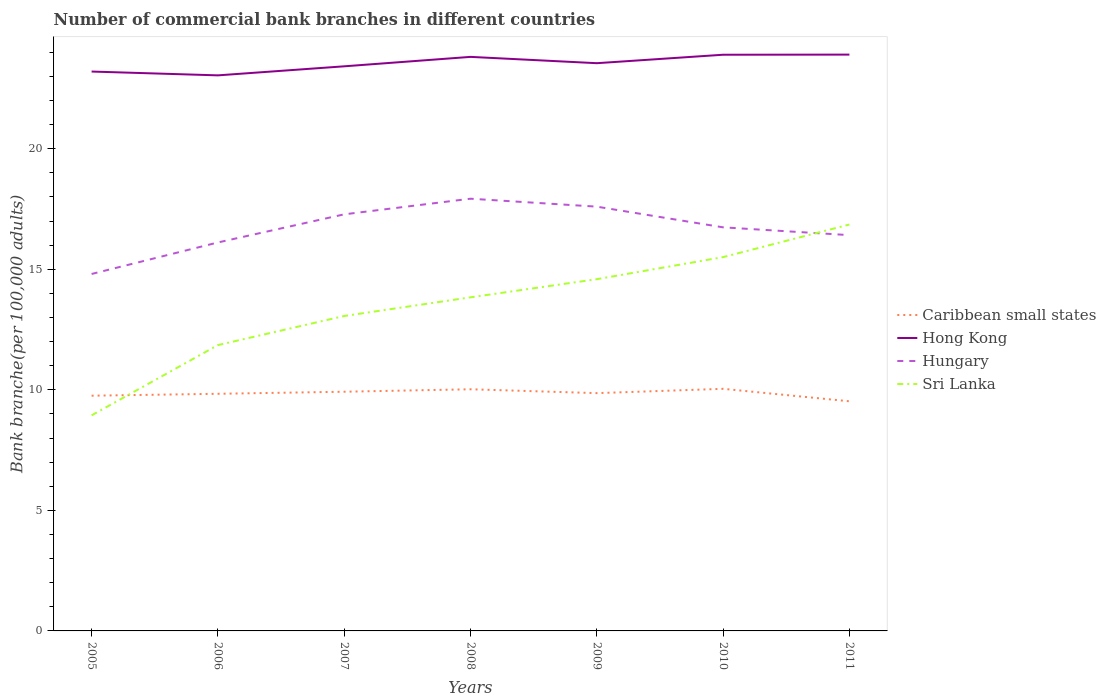Does the line corresponding to Sri Lanka intersect with the line corresponding to Hungary?
Keep it short and to the point. Yes. Across all years, what is the maximum number of commercial bank branches in Hong Kong?
Give a very brief answer. 23.05. In which year was the number of commercial bank branches in Hungary maximum?
Offer a very short reply. 2005. What is the total number of commercial bank branches in Hungary in the graph?
Give a very brief answer. -0.3. What is the difference between the highest and the second highest number of commercial bank branches in Hong Kong?
Make the answer very short. 0.86. What is the difference between the highest and the lowest number of commercial bank branches in Hong Kong?
Provide a short and direct response. 4. Is the number of commercial bank branches in Hong Kong strictly greater than the number of commercial bank branches in Caribbean small states over the years?
Make the answer very short. No. How many lines are there?
Your response must be concise. 4. How are the legend labels stacked?
Make the answer very short. Vertical. What is the title of the graph?
Your answer should be compact. Number of commercial bank branches in different countries. What is the label or title of the X-axis?
Make the answer very short. Years. What is the label or title of the Y-axis?
Make the answer very short. Bank branche(per 100,0 adults). What is the Bank branche(per 100,000 adults) of Caribbean small states in 2005?
Give a very brief answer. 9.76. What is the Bank branche(per 100,000 adults) of Hong Kong in 2005?
Keep it short and to the point. 23.2. What is the Bank branche(per 100,000 adults) of Hungary in 2005?
Offer a terse response. 14.81. What is the Bank branche(per 100,000 adults) in Sri Lanka in 2005?
Provide a short and direct response. 8.94. What is the Bank branche(per 100,000 adults) of Caribbean small states in 2006?
Your answer should be very brief. 9.84. What is the Bank branche(per 100,000 adults) of Hong Kong in 2006?
Ensure brevity in your answer.  23.05. What is the Bank branche(per 100,000 adults) of Hungary in 2006?
Keep it short and to the point. 16.11. What is the Bank branche(per 100,000 adults) in Sri Lanka in 2006?
Provide a short and direct response. 11.86. What is the Bank branche(per 100,000 adults) in Caribbean small states in 2007?
Make the answer very short. 9.92. What is the Bank branche(per 100,000 adults) in Hong Kong in 2007?
Your response must be concise. 23.42. What is the Bank branche(per 100,000 adults) in Hungary in 2007?
Offer a very short reply. 17.28. What is the Bank branche(per 100,000 adults) of Sri Lanka in 2007?
Offer a very short reply. 13.06. What is the Bank branche(per 100,000 adults) in Caribbean small states in 2008?
Your answer should be compact. 10.02. What is the Bank branche(per 100,000 adults) of Hong Kong in 2008?
Your answer should be compact. 23.81. What is the Bank branche(per 100,000 adults) in Hungary in 2008?
Offer a very short reply. 17.93. What is the Bank branche(per 100,000 adults) of Sri Lanka in 2008?
Make the answer very short. 13.84. What is the Bank branche(per 100,000 adults) in Caribbean small states in 2009?
Provide a short and direct response. 9.86. What is the Bank branche(per 100,000 adults) of Hong Kong in 2009?
Give a very brief answer. 23.55. What is the Bank branche(per 100,000 adults) in Hungary in 2009?
Ensure brevity in your answer.  17.6. What is the Bank branche(per 100,000 adults) of Sri Lanka in 2009?
Keep it short and to the point. 14.59. What is the Bank branche(per 100,000 adults) of Caribbean small states in 2010?
Ensure brevity in your answer.  10.04. What is the Bank branche(per 100,000 adults) in Hong Kong in 2010?
Your answer should be very brief. 23.9. What is the Bank branche(per 100,000 adults) in Hungary in 2010?
Give a very brief answer. 16.74. What is the Bank branche(per 100,000 adults) in Sri Lanka in 2010?
Provide a short and direct response. 15.51. What is the Bank branche(per 100,000 adults) in Caribbean small states in 2011?
Offer a terse response. 9.53. What is the Bank branche(per 100,000 adults) in Hong Kong in 2011?
Give a very brief answer. 23.91. What is the Bank branche(per 100,000 adults) of Hungary in 2011?
Ensure brevity in your answer.  16.42. What is the Bank branche(per 100,000 adults) in Sri Lanka in 2011?
Provide a short and direct response. 16.86. Across all years, what is the maximum Bank branche(per 100,000 adults) of Caribbean small states?
Offer a terse response. 10.04. Across all years, what is the maximum Bank branche(per 100,000 adults) of Hong Kong?
Offer a terse response. 23.91. Across all years, what is the maximum Bank branche(per 100,000 adults) of Hungary?
Provide a short and direct response. 17.93. Across all years, what is the maximum Bank branche(per 100,000 adults) of Sri Lanka?
Your response must be concise. 16.86. Across all years, what is the minimum Bank branche(per 100,000 adults) in Caribbean small states?
Your answer should be very brief. 9.53. Across all years, what is the minimum Bank branche(per 100,000 adults) in Hong Kong?
Provide a short and direct response. 23.05. Across all years, what is the minimum Bank branche(per 100,000 adults) in Hungary?
Provide a short and direct response. 14.81. Across all years, what is the minimum Bank branche(per 100,000 adults) of Sri Lanka?
Make the answer very short. 8.94. What is the total Bank branche(per 100,000 adults) of Caribbean small states in the graph?
Offer a terse response. 68.97. What is the total Bank branche(per 100,000 adults) of Hong Kong in the graph?
Your response must be concise. 164.84. What is the total Bank branche(per 100,000 adults) in Hungary in the graph?
Your answer should be very brief. 116.89. What is the total Bank branche(per 100,000 adults) in Sri Lanka in the graph?
Keep it short and to the point. 94.66. What is the difference between the Bank branche(per 100,000 adults) in Caribbean small states in 2005 and that in 2006?
Your answer should be very brief. -0.08. What is the difference between the Bank branche(per 100,000 adults) of Hong Kong in 2005 and that in 2006?
Ensure brevity in your answer.  0.16. What is the difference between the Bank branche(per 100,000 adults) in Hungary in 2005 and that in 2006?
Offer a very short reply. -1.31. What is the difference between the Bank branche(per 100,000 adults) of Sri Lanka in 2005 and that in 2006?
Your response must be concise. -2.91. What is the difference between the Bank branche(per 100,000 adults) in Caribbean small states in 2005 and that in 2007?
Make the answer very short. -0.16. What is the difference between the Bank branche(per 100,000 adults) of Hong Kong in 2005 and that in 2007?
Keep it short and to the point. -0.22. What is the difference between the Bank branche(per 100,000 adults) in Hungary in 2005 and that in 2007?
Provide a succinct answer. -2.47. What is the difference between the Bank branche(per 100,000 adults) of Sri Lanka in 2005 and that in 2007?
Give a very brief answer. -4.12. What is the difference between the Bank branche(per 100,000 adults) in Caribbean small states in 2005 and that in 2008?
Your answer should be very brief. -0.27. What is the difference between the Bank branche(per 100,000 adults) of Hong Kong in 2005 and that in 2008?
Offer a terse response. -0.61. What is the difference between the Bank branche(per 100,000 adults) in Hungary in 2005 and that in 2008?
Keep it short and to the point. -3.12. What is the difference between the Bank branche(per 100,000 adults) of Sri Lanka in 2005 and that in 2008?
Keep it short and to the point. -4.9. What is the difference between the Bank branche(per 100,000 adults) of Caribbean small states in 2005 and that in 2009?
Your answer should be very brief. -0.11. What is the difference between the Bank branche(per 100,000 adults) in Hong Kong in 2005 and that in 2009?
Offer a terse response. -0.35. What is the difference between the Bank branche(per 100,000 adults) of Hungary in 2005 and that in 2009?
Provide a succinct answer. -2.79. What is the difference between the Bank branche(per 100,000 adults) of Sri Lanka in 2005 and that in 2009?
Your answer should be compact. -5.65. What is the difference between the Bank branche(per 100,000 adults) of Caribbean small states in 2005 and that in 2010?
Offer a terse response. -0.29. What is the difference between the Bank branche(per 100,000 adults) in Hong Kong in 2005 and that in 2010?
Your response must be concise. -0.7. What is the difference between the Bank branche(per 100,000 adults) of Hungary in 2005 and that in 2010?
Your answer should be compact. -1.93. What is the difference between the Bank branche(per 100,000 adults) in Sri Lanka in 2005 and that in 2010?
Your answer should be compact. -6.56. What is the difference between the Bank branche(per 100,000 adults) in Caribbean small states in 2005 and that in 2011?
Offer a terse response. 0.23. What is the difference between the Bank branche(per 100,000 adults) of Hong Kong in 2005 and that in 2011?
Provide a short and direct response. -0.7. What is the difference between the Bank branche(per 100,000 adults) in Hungary in 2005 and that in 2011?
Offer a terse response. -1.61. What is the difference between the Bank branche(per 100,000 adults) of Sri Lanka in 2005 and that in 2011?
Provide a succinct answer. -7.92. What is the difference between the Bank branche(per 100,000 adults) of Caribbean small states in 2006 and that in 2007?
Provide a succinct answer. -0.09. What is the difference between the Bank branche(per 100,000 adults) in Hong Kong in 2006 and that in 2007?
Offer a terse response. -0.38. What is the difference between the Bank branche(per 100,000 adults) in Hungary in 2006 and that in 2007?
Offer a terse response. -1.17. What is the difference between the Bank branche(per 100,000 adults) in Sri Lanka in 2006 and that in 2007?
Give a very brief answer. -1.21. What is the difference between the Bank branche(per 100,000 adults) in Caribbean small states in 2006 and that in 2008?
Provide a succinct answer. -0.19. What is the difference between the Bank branche(per 100,000 adults) of Hong Kong in 2006 and that in 2008?
Provide a succinct answer. -0.77. What is the difference between the Bank branche(per 100,000 adults) of Hungary in 2006 and that in 2008?
Provide a short and direct response. -1.82. What is the difference between the Bank branche(per 100,000 adults) in Sri Lanka in 2006 and that in 2008?
Your answer should be very brief. -1.98. What is the difference between the Bank branche(per 100,000 adults) of Caribbean small states in 2006 and that in 2009?
Give a very brief answer. -0.03. What is the difference between the Bank branche(per 100,000 adults) of Hong Kong in 2006 and that in 2009?
Offer a terse response. -0.5. What is the difference between the Bank branche(per 100,000 adults) in Hungary in 2006 and that in 2009?
Offer a terse response. -1.49. What is the difference between the Bank branche(per 100,000 adults) of Sri Lanka in 2006 and that in 2009?
Give a very brief answer. -2.73. What is the difference between the Bank branche(per 100,000 adults) of Caribbean small states in 2006 and that in 2010?
Give a very brief answer. -0.21. What is the difference between the Bank branche(per 100,000 adults) in Hong Kong in 2006 and that in 2010?
Keep it short and to the point. -0.86. What is the difference between the Bank branche(per 100,000 adults) of Hungary in 2006 and that in 2010?
Offer a very short reply. -0.63. What is the difference between the Bank branche(per 100,000 adults) of Sri Lanka in 2006 and that in 2010?
Ensure brevity in your answer.  -3.65. What is the difference between the Bank branche(per 100,000 adults) of Caribbean small states in 2006 and that in 2011?
Your answer should be compact. 0.31. What is the difference between the Bank branche(per 100,000 adults) of Hong Kong in 2006 and that in 2011?
Give a very brief answer. -0.86. What is the difference between the Bank branche(per 100,000 adults) in Hungary in 2006 and that in 2011?
Your response must be concise. -0.3. What is the difference between the Bank branche(per 100,000 adults) of Sri Lanka in 2006 and that in 2011?
Give a very brief answer. -5. What is the difference between the Bank branche(per 100,000 adults) in Caribbean small states in 2007 and that in 2008?
Your answer should be very brief. -0.1. What is the difference between the Bank branche(per 100,000 adults) in Hong Kong in 2007 and that in 2008?
Offer a very short reply. -0.39. What is the difference between the Bank branche(per 100,000 adults) in Hungary in 2007 and that in 2008?
Make the answer very short. -0.65. What is the difference between the Bank branche(per 100,000 adults) of Sri Lanka in 2007 and that in 2008?
Ensure brevity in your answer.  -0.77. What is the difference between the Bank branche(per 100,000 adults) of Caribbean small states in 2007 and that in 2009?
Provide a succinct answer. 0.06. What is the difference between the Bank branche(per 100,000 adults) of Hong Kong in 2007 and that in 2009?
Provide a succinct answer. -0.13. What is the difference between the Bank branche(per 100,000 adults) of Hungary in 2007 and that in 2009?
Offer a terse response. -0.32. What is the difference between the Bank branche(per 100,000 adults) of Sri Lanka in 2007 and that in 2009?
Your response must be concise. -1.53. What is the difference between the Bank branche(per 100,000 adults) of Caribbean small states in 2007 and that in 2010?
Make the answer very short. -0.12. What is the difference between the Bank branche(per 100,000 adults) of Hong Kong in 2007 and that in 2010?
Your answer should be very brief. -0.48. What is the difference between the Bank branche(per 100,000 adults) in Hungary in 2007 and that in 2010?
Your response must be concise. 0.54. What is the difference between the Bank branche(per 100,000 adults) of Sri Lanka in 2007 and that in 2010?
Your response must be concise. -2.44. What is the difference between the Bank branche(per 100,000 adults) of Caribbean small states in 2007 and that in 2011?
Provide a short and direct response. 0.4. What is the difference between the Bank branche(per 100,000 adults) of Hong Kong in 2007 and that in 2011?
Provide a short and direct response. -0.49. What is the difference between the Bank branche(per 100,000 adults) in Hungary in 2007 and that in 2011?
Provide a short and direct response. 0.86. What is the difference between the Bank branche(per 100,000 adults) in Sri Lanka in 2007 and that in 2011?
Keep it short and to the point. -3.79. What is the difference between the Bank branche(per 100,000 adults) of Caribbean small states in 2008 and that in 2009?
Your response must be concise. 0.16. What is the difference between the Bank branche(per 100,000 adults) of Hong Kong in 2008 and that in 2009?
Keep it short and to the point. 0.26. What is the difference between the Bank branche(per 100,000 adults) in Hungary in 2008 and that in 2009?
Offer a very short reply. 0.33. What is the difference between the Bank branche(per 100,000 adults) in Sri Lanka in 2008 and that in 2009?
Your response must be concise. -0.75. What is the difference between the Bank branche(per 100,000 adults) of Caribbean small states in 2008 and that in 2010?
Offer a terse response. -0.02. What is the difference between the Bank branche(per 100,000 adults) in Hong Kong in 2008 and that in 2010?
Keep it short and to the point. -0.09. What is the difference between the Bank branche(per 100,000 adults) of Hungary in 2008 and that in 2010?
Keep it short and to the point. 1.19. What is the difference between the Bank branche(per 100,000 adults) in Sri Lanka in 2008 and that in 2010?
Offer a very short reply. -1.67. What is the difference between the Bank branche(per 100,000 adults) of Caribbean small states in 2008 and that in 2011?
Your answer should be compact. 0.5. What is the difference between the Bank branche(per 100,000 adults) in Hong Kong in 2008 and that in 2011?
Your response must be concise. -0.09. What is the difference between the Bank branche(per 100,000 adults) of Hungary in 2008 and that in 2011?
Your answer should be very brief. 1.51. What is the difference between the Bank branche(per 100,000 adults) in Sri Lanka in 2008 and that in 2011?
Provide a short and direct response. -3.02. What is the difference between the Bank branche(per 100,000 adults) of Caribbean small states in 2009 and that in 2010?
Make the answer very short. -0.18. What is the difference between the Bank branche(per 100,000 adults) of Hong Kong in 2009 and that in 2010?
Offer a terse response. -0.35. What is the difference between the Bank branche(per 100,000 adults) in Hungary in 2009 and that in 2010?
Your answer should be compact. 0.86. What is the difference between the Bank branche(per 100,000 adults) of Sri Lanka in 2009 and that in 2010?
Provide a succinct answer. -0.92. What is the difference between the Bank branche(per 100,000 adults) in Caribbean small states in 2009 and that in 2011?
Your answer should be compact. 0.34. What is the difference between the Bank branche(per 100,000 adults) of Hong Kong in 2009 and that in 2011?
Provide a succinct answer. -0.36. What is the difference between the Bank branche(per 100,000 adults) of Hungary in 2009 and that in 2011?
Offer a very short reply. 1.18. What is the difference between the Bank branche(per 100,000 adults) in Sri Lanka in 2009 and that in 2011?
Give a very brief answer. -2.27. What is the difference between the Bank branche(per 100,000 adults) of Caribbean small states in 2010 and that in 2011?
Provide a short and direct response. 0.52. What is the difference between the Bank branche(per 100,000 adults) of Hong Kong in 2010 and that in 2011?
Your answer should be very brief. -0.01. What is the difference between the Bank branche(per 100,000 adults) of Hungary in 2010 and that in 2011?
Provide a short and direct response. 0.32. What is the difference between the Bank branche(per 100,000 adults) in Sri Lanka in 2010 and that in 2011?
Your answer should be very brief. -1.35. What is the difference between the Bank branche(per 100,000 adults) in Caribbean small states in 2005 and the Bank branche(per 100,000 adults) in Hong Kong in 2006?
Make the answer very short. -13.29. What is the difference between the Bank branche(per 100,000 adults) in Caribbean small states in 2005 and the Bank branche(per 100,000 adults) in Hungary in 2006?
Your response must be concise. -6.36. What is the difference between the Bank branche(per 100,000 adults) in Caribbean small states in 2005 and the Bank branche(per 100,000 adults) in Sri Lanka in 2006?
Your answer should be compact. -2.1. What is the difference between the Bank branche(per 100,000 adults) of Hong Kong in 2005 and the Bank branche(per 100,000 adults) of Hungary in 2006?
Ensure brevity in your answer.  7.09. What is the difference between the Bank branche(per 100,000 adults) of Hong Kong in 2005 and the Bank branche(per 100,000 adults) of Sri Lanka in 2006?
Keep it short and to the point. 11.35. What is the difference between the Bank branche(per 100,000 adults) in Hungary in 2005 and the Bank branche(per 100,000 adults) in Sri Lanka in 2006?
Keep it short and to the point. 2.95. What is the difference between the Bank branche(per 100,000 adults) in Caribbean small states in 2005 and the Bank branche(per 100,000 adults) in Hong Kong in 2007?
Your answer should be very brief. -13.66. What is the difference between the Bank branche(per 100,000 adults) in Caribbean small states in 2005 and the Bank branche(per 100,000 adults) in Hungary in 2007?
Your response must be concise. -7.52. What is the difference between the Bank branche(per 100,000 adults) of Caribbean small states in 2005 and the Bank branche(per 100,000 adults) of Sri Lanka in 2007?
Give a very brief answer. -3.31. What is the difference between the Bank branche(per 100,000 adults) of Hong Kong in 2005 and the Bank branche(per 100,000 adults) of Hungary in 2007?
Your response must be concise. 5.92. What is the difference between the Bank branche(per 100,000 adults) of Hong Kong in 2005 and the Bank branche(per 100,000 adults) of Sri Lanka in 2007?
Give a very brief answer. 10.14. What is the difference between the Bank branche(per 100,000 adults) of Hungary in 2005 and the Bank branche(per 100,000 adults) of Sri Lanka in 2007?
Keep it short and to the point. 1.74. What is the difference between the Bank branche(per 100,000 adults) in Caribbean small states in 2005 and the Bank branche(per 100,000 adults) in Hong Kong in 2008?
Your answer should be compact. -14.05. What is the difference between the Bank branche(per 100,000 adults) in Caribbean small states in 2005 and the Bank branche(per 100,000 adults) in Hungary in 2008?
Keep it short and to the point. -8.17. What is the difference between the Bank branche(per 100,000 adults) in Caribbean small states in 2005 and the Bank branche(per 100,000 adults) in Sri Lanka in 2008?
Keep it short and to the point. -4.08. What is the difference between the Bank branche(per 100,000 adults) in Hong Kong in 2005 and the Bank branche(per 100,000 adults) in Hungary in 2008?
Offer a very short reply. 5.27. What is the difference between the Bank branche(per 100,000 adults) in Hong Kong in 2005 and the Bank branche(per 100,000 adults) in Sri Lanka in 2008?
Provide a succinct answer. 9.37. What is the difference between the Bank branche(per 100,000 adults) in Hungary in 2005 and the Bank branche(per 100,000 adults) in Sri Lanka in 2008?
Provide a short and direct response. 0.97. What is the difference between the Bank branche(per 100,000 adults) of Caribbean small states in 2005 and the Bank branche(per 100,000 adults) of Hong Kong in 2009?
Your response must be concise. -13.79. What is the difference between the Bank branche(per 100,000 adults) of Caribbean small states in 2005 and the Bank branche(per 100,000 adults) of Hungary in 2009?
Provide a short and direct response. -7.84. What is the difference between the Bank branche(per 100,000 adults) in Caribbean small states in 2005 and the Bank branche(per 100,000 adults) in Sri Lanka in 2009?
Keep it short and to the point. -4.83. What is the difference between the Bank branche(per 100,000 adults) of Hong Kong in 2005 and the Bank branche(per 100,000 adults) of Hungary in 2009?
Your answer should be compact. 5.6. What is the difference between the Bank branche(per 100,000 adults) in Hong Kong in 2005 and the Bank branche(per 100,000 adults) in Sri Lanka in 2009?
Your response must be concise. 8.61. What is the difference between the Bank branche(per 100,000 adults) in Hungary in 2005 and the Bank branche(per 100,000 adults) in Sri Lanka in 2009?
Offer a very short reply. 0.22. What is the difference between the Bank branche(per 100,000 adults) in Caribbean small states in 2005 and the Bank branche(per 100,000 adults) in Hong Kong in 2010?
Ensure brevity in your answer.  -14.14. What is the difference between the Bank branche(per 100,000 adults) in Caribbean small states in 2005 and the Bank branche(per 100,000 adults) in Hungary in 2010?
Keep it short and to the point. -6.98. What is the difference between the Bank branche(per 100,000 adults) of Caribbean small states in 2005 and the Bank branche(per 100,000 adults) of Sri Lanka in 2010?
Offer a very short reply. -5.75. What is the difference between the Bank branche(per 100,000 adults) in Hong Kong in 2005 and the Bank branche(per 100,000 adults) in Hungary in 2010?
Offer a terse response. 6.46. What is the difference between the Bank branche(per 100,000 adults) of Hong Kong in 2005 and the Bank branche(per 100,000 adults) of Sri Lanka in 2010?
Provide a short and direct response. 7.7. What is the difference between the Bank branche(per 100,000 adults) in Hungary in 2005 and the Bank branche(per 100,000 adults) in Sri Lanka in 2010?
Provide a succinct answer. -0.7. What is the difference between the Bank branche(per 100,000 adults) of Caribbean small states in 2005 and the Bank branche(per 100,000 adults) of Hong Kong in 2011?
Your answer should be compact. -14.15. What is the difference between the Bank branche(per 100,000 adults) of Caribbean small states in 2005 and the Bank branche(per 100,000 adults) of Hungary in 2011?
Offer a very short reply. -6.66. What is the difference between the Bank branche(per 100,000 adults) in Caribbean small states in 2005 and the Bank branche(per 100,000 adults) in Sri Lanka in 2011?
Your answer should be compact. -7.1. What is the difference between the Bank branche(per 100,000 adults) in Hong Kong in 2005 and the Bank branche(per 100,000 adults) in Hungary in 2011?
Give a very brief answer. 6.79. What is the difference between the Bank branche(per 100,000 adults) in Hong Kong in 2005 and the Bank branche(per 100,000 adults) in Sri Lanka in 2011?
Give a very brief answer. 6.35. What is the difference between the Bank branche(per 100,000 adults) of Hungary in 2005 and the Bank branche(per 100,000 adults) of Sri Lanka in 2011?
Provide a succinct answer. -2.05. What is the difference between the Bank branche(per 100,000 adults) of Caribbean small states in 2006 and the Bank branche(per 100,000 adults) of Hong Kong in 2007?
Keep it short and to the point. -13.58. What is the difference between the Bank branche(per 100,000 adults) of Caribbean small states in 2006 and the Bank branche(per 100,000 adults) of Hungary in 2007?
Offer a terse response. -7.44. What is the difference between the Bank branche(per 100,000 adults) of Caribbean small states in 2006 and the Bank branche(per 100,000 adults) of Sri Lanka in 2007?
Make the answer very short. -3.23. What is the difference between the Bank branche(per 100,000 adults) in Hong Kong in 2006 and the Bank branche(per 100,000 adults) in Hungary in 2007?
Keep it short and to the point. 5.76. What is the difference between the Bank branche(per 100,000 adults) in Hong Kong in 2006 and the Bank branche(per 100,000 adults) in Sri Lanka in 2007?
Your response must be concise. 9.98. What is the difference between the Bank branche(per 100,000 adults) of Hungary in 2006 and the Bank branche(per 100,000 adults) of Sri Lanka in 2007?
Provide a succinct answer. 3.05. What is the difference between the Bank branche(per 100,000 adults) of Caribbean small states in 2006 and the Bank branche(per 100,000 adults) of Hong Kong in 2008?
Your answer should be very brief. -13.98. What is the difference between the Bank branche(per 100,000 adults) in Caribbean small states in 2006 and the Bank branche(per 100,000 adults) in Hungary in 2008?
Ensure brevity in your answer.  -8.09. What is the difference between the Bank branche(per 100,000 adults) of Caribbean small states in 2006 and the Bank branche(per 100,000 adults) of Sri Lanka in 2008?
Your answer should be very brief. -4. What is the difference between the Bank branche(per 100,000 adults) of Hong Kong in 2006 and the Bank branche(per 100,000 adults) of Hungary in 2008?
Your response must be concise. 5.12. What is the difference between the Bank branche(per 100,000 adults) of Hong Kong in 2006 and the Bank branche(per 100,000 adults) of Sri Lanka in 2008?
Your answer should be compact. 9.21. What is the difference between the Bank branche(per 100,000 adults) of Hungary in 2006 and the Bank branche(per 100,000 adults) of Sri Lanka in 2008?
Your answer should be very brief. 2.28. What is the difference between the Bank branche(per 100,000 adults) of Caribbean small states in 2006 and the Bank branche(per 100,000 adults) of Hong Kong in 2009?
Your answer should be very brief. -13.71. What is the difference between the Bank branche(per 100,000 adults) in Caribbean small states in 2006 and the Bank branche(per 100,000 adults) in Hungary in 2009?
Give a very brief answer. -7.76. What is the difference between the Bank branche(per 100,000 adults) of Caribbean small states in 2006 and the Bank branche(per 100,000 adults) of Sri Lanka in 2009?
Your answer should be very brief. -4.75. What is the difference between the Bank branche(per 100,000 adults) of Hong Kong in 2006 and the Bank branche(per 100,000 adults) of Hungary in 2009?
Offer a very short reply. 5.45. What is the difference between the Bank branche(per 100,000 adults) in Hong Kong in 2006 and the Bank branche(per 100,000 adults) in Sri Lanka in 2009?
Your response must be concise. 8.46. What is the difference between the Bank branche(per 100,000 adults) of Hungary in 2006 and the Bank branche(per 100,000 adults) of Sri Lanka in 2009?
Ensure brevity in your answer.  1.52. What is the difference between the Bank branche(per 100,000 adults) of Caribbean small states in 2006 and the Bank branche(per 100,000 adults) of Hong Kong in 2010?
Give a very brief answer. -14.06. What is the difference between the Bank branche(per 100,000 adults) of Caribbean small states in 2006 and the Bank branche(per 100,000 adults) of Hungary in 2010?
Your answer should be compact. -6.9. What is the difference between the Bank branche(per 100,000 adults) of Caribbean small states in 2006 and the Bank branche(per 100,000 adults) of Sri Lanka in 2010?
Provide a short and direct response. -5.67. What is the difference between the Bank branche(per 100,000 adults) of Hong Kong in 2006 and the Bank branche(per 100,000 adults) of Hungary in 2010?
Provide a succinct answer. 6.3. What is the difference between the Bank branche(per 100,000 adults) of Hong Kong in 2006 and the Bank branche(per 100,000 adults) of Sri Lanka in 2010?
Offer a very short reply. 7.54. What is the difference between the Bank branche(per 100,000 adults) in Hungary in 2006 and the Bank branche(per 100,000 adults) in Sri Lanka in 2010?
Offer a very short reply. 0.61. What is the difference between the Bank branche(per 100,000 adults) of Caribbean small states in 2006 and the Bank branche(per 100,000 adults) of Hong Kong in 2011?
Offer a very short reply. -14.07. What is the difference between the Bank branche(per 100,000 adults) of Caribbean small states in 2006 and the Bank branche(per 100,000 adults) of Hungary in 2011?
Make the answer very short. -6.58. What is the difference between the Bank branche(per 100,000 adults) of Caribbean small states in 2006 and the Bank branche(per 100,000 adults) of Sri Lanka in 2011?
Your answer should be compact. -7.02. What is the difference between the Bank branche(per 100,000 adults) of Hong Kong in 2006 and the Bank branche(per 100,000 adults) of Hungary in 2011?
Give a very brief answer. 6.63. What is the difference between the Bank branche(per 100,000 adults) of Hong Kong in 2006 and the Bank branche(per 100,000 adults) of Sri Lanka in 2011?
Make the answer very short. 6.19. What is the difference between the Bank branche(per 100,000 adults) in Hungary in 2006 and the Bank branche(per 100,000 adults) in Sri Lanka in 2011?
Provide a short and direct response. -0.74. What is the difference between the Bank branche(per 100,000 adults) in Caribbean small states in 2007 and the Bank branche(per 100,000 adults) in Hong Kong in 2008?
Your answer should be very brief. -13.89. What is the difference between the Bank branche(per 100,000 adults) in Caribbean small states in 2007 and the Bank branche(per 100,000 adults) in Hungary in 2008?
Provide a succinct answer. -8.01. What is the difference between the Bank branche(per 100,000 adults) in Caribbean small states in 2007 and the Bank branche(per 100,000 adults) in Sri Lanka in 2008?
Your answer should be compact. -3.92. What is the difference between the Bank branche(per 100,000 adults) in Hong Kong in 2007 and the Bank branche(per 100,000 adults) in Hungary in 2008?
Keep it short and to the point. 5.49. What is the difference between the Bank branche(per 100,000 adults) in Hong Kong in 2007 and the Bank branche(per 100,000 adults) in Sri Lanka in 2008?
Your answer should be compact. 9.58. What is the difference between the Bank branche(per 100,000 adults) in Hungary in 2007 and the Bank branche(per 100,000 adults) in Sri Lanka in 2008?
Your answer should be very brief. 3.44. What is the difference between the Bank branche(per 100,000 adults) in Caribbean small states in 2007 and the Bank branche(per 100,000 adults) in Hong Kong in 2009?
Make the answer very short. -13.63. What is the difference between the Bank branche(per 100,000 adults) of Caribbean small states in 2007 and the Bank branche(per 100,000 adults) of Hungary in 2009?
Your answer should be compact. -7.68. What is the difference between the Bank branche(per 100,000 adults) of Caribbean small states in 2007 and the Bank branche(per 100,000 adults) of Sri Lanka in 2009?
Ensure brevity in your answer.  -4.67. What is the difference between the Bank branche(per 100,000 adults) in Hong Kong in 2007 and the Bank branche(per 100,000 adults) in Hungary in 2009?
Provide a short and direct response. 5.82. What is the difference between the Bank branche(per 100,000 adults) of Hong Kong in 2007 and the Bank branche(per 100,000 adults) of Sri Lanka in 2009?
Make the answer very short. 8.83. What is the difference between the Bank branche(per 100,000 adults) in Hungary in 2007 and the Bank branche(per 100,000 adults) in Sri Lanka in 2009?
Provide a succinct answer. 2.69. What is the difference between the Bank branche(per 100,000 adults) of Caribbean small states in 2007 and the Bank branche(per 100,000 adults) of Hong Kong in 2010?
Keep it short and to the point. -13.98. What is the difference between the Bank branche(per 100,000 adults) of Caribbean small states in 2007 and the Bank branche(per 100,000 adults) of Hungary in 2010?
Provide a succinct answer. -6.82. What is the difference between the Bank branche(per 100,000 adults) in Caribbean small states in 2007 and the Bank branche(per 100,000 adults) in Sri Lanka in 2010?
Offer a very short reply. -5.58. What is the difference between the Bank branche(per 100,000 adults) in Hong Kong in 2007 and the Bank branche(per 100,000 adults) in Hungary in 2010?
Give a very brief answer. 6.68. What is the difference between the Bank branche(per 100,000 adults) of Hong Kong in 2007 and the Bank branche(per 100,000 adults) of Sri Lanka in 2010?
Keep it short and to the point. 7.91. What is the difference between the Bank branche(per 100,000 adults) of Hungary in 2007 and the Bank branche(per 100,000 adults) of Sri Lanka in 2010?
Make the answer very short. 1.77. What is the difference between the Bank branche(per 100,000 adults) of Caribbean small states in 2007 and the Bank branche(per 100,000 adults) of Hong Kong in 2011?
Offer a terse response. -13.98. What is the difference between the Bank branche(per 100,000 adults) of Caribbean small states in 2007 and the Bank branche(per 100,000 adults) of Hungary in 2011?
Make the answer very short. -6.5. What is the difference between the Bank branche(per 100,000 adults) of Caribbean small states in 2007 and the Bank branche(per 100,000 adults) of Sri Lanka in 2011?
Make the answer very short. -6.94. What is the difference between the Bank branche(per 100,000 adults) of Hong Kong in 2007 and the Bank branche(per 100,000 adults) of Hungary in 2011?
Offer a very short reply. 7. What is the difference between the Bank branche(per 100,000 adults) of Hong Kong in 2007 and the Bank branche(per 100,000 adults) of Sri Lanka in 2011?
Ensure brevity in your answer.  6.56. What is the difference between the Bank branche(per 100,000 adults) of Hungary in 2007 and the Bank branche(per 100,000 adults) of Sri Lanka in 2011?
Your answer should be very brief. 0.42. What is the difference between the Bank branche(per 100,000 adults) of Caribbean small states in 2008 and the Bank branche(per 100,000 adults) of Hong Kong in 2009?
Provide a succinct answer. -13.53. What is the difference between the Bank branche(per 100,000 adults) in Caribbean small states in 2008 and the Bank branche(per 100,000 adults) in Hungary in 2009?
Give a very brief answer. -7.58. What is the difference between the Bank branche(per 100,000 adults) of Caribbean small states in 2008 and the Bank branche(per 100,000 adults) of Sri Lanka in 2009?
Ensure brevity in your answer.  -4.57. What is the difference between the Bank branche(per 100,000 adults) of Hong Kong in 2008 and the Bank branche(per 100,000 adults) of Hungary in 2009?
Your response must be concise. 6.21. What is the difference between the Bank branche(per 100,000 adults) of Hong Kong in 2008 and the Bank branche(per 100,000 adults) of Sri Lanka in 2009?
Offer a very short reply. 9.22. What is the difference between the Bank branche(per 100,000 adults) in Hungary in 2008 and the Bank branche(per 100,000 adults) in Sri Lanka in 2009?
Keep it short and to the point. 3.34. What is the difference between the Bank branche(per 100,000 adults) of Caribbean small states in 2008 and the Bank branche(per 100,000 adults) of Hong Kong in 2010?
Keep it short and to the point. -13.88. What is the difference between the Bank branche(per 100,000 adults) of Caribbean small states in 2008 and the Bank branche(per 100,000 adults) of Hungary in 2010?
Offer a very short reply. -6.72. What is the difference between the Bank branche(per 100,000 adults) of Caribbean small states in 2008 and the Bank branche(per 100,000 adults) of Sri Lanka in 2010?
Give a very brief answer. -5.48. What is the difference between the Bank branche(per 100,000 adults) in Hong Kong in 2008 and the Bank branche(per 100,000 adults) in Hungary in 2010?
Keep it short and to the point. 7.07. What is the difference between the Bank branche(per 100,000 adults) in Hong Kong in 2008 and the Bank branche(per 100,000 adults) in Sri Lanka in 2010?
Give a very brief answer. 8.31. What is the difference between the Bank branche(per 100,000 adults) in Hungary in 2008 and the Bank branche(per 100,000 adults) in Sri Lanka in 2010?
Make the answer very short. 2.42. What is the difference between the Bank branche(per 100,000 adults) in Caribbean small states in 2008 and the Bank branche(per 100,000 adults) in Hong Kong in 2011?
Offer a very short reply. -13.88. What is the difference between the Bank branche(per 100,000 adults) in Caribbean small states in 2008 and the Bank branche(per 100,000 adults) in Hungary in 2011?
Provide a short and direct response. -6.39. What is the difference between the Bank branche(per 100,000 adults) in Caribbean small states in 2008 and the Bank branche(per 100,000 adults) in Sri Lanka in 2011?
Ensure brevity in your answer.  -6.83. What is the difference between the Bank branche(per 100,000 adults) in Hong Kong in 2008 and the Bank branche(per 100,000 adults) in Hungary in 2011?
Ensure brevity in your answer.  7.39. What is the difference between the Bank branche(per 100,000 adults) of Hong Kong in 2008 and the Bank branche(per 100,000 adults) of Sri Lanka in 2011?
Your answer should be very brief. 6.95. What is the difference between the Bank branche(per 100,000 adults) of Hungary in 2008 and the Bank branche(per 100,000 adults) of Sri Lanka in 2011?
Give a very brief answer. 1.07. What is the difference between the Bank branche(per 100,000 adults) in Caribbean small states in 2009 and the Bank branche(per 100,000 adults) in Hong Kong in 2010?
Provide a short and direct response. -14.04. What is the difference between the Bank branche(per 100,000 adults) in Caribbean small states in 2009 and the Bank branche(per 100,000 adults) in Hungary in 2010?
Make the answer very short. -6.88. What is the difference between the Bank branche(per 100,000 adults) in Caribbean small states in 2009 and the Bank branche(per 100,000 adults) in Sri Lanka in 2010?
Your response must be concise. -5.64. What is the difference between the Bank branche(per 100,000 adults) of Hong Kong in 2009 and the Bank branche(per 100,000 adults) of Hungary in 2010?
Give a very brief answer. 6.81. What is the difference between the Bank branche(per 100,000 adults) in Hong Kong in 2009 and the Bank branche(per 100,000 adults) in Sri Lanka in 2010?
Your response must be concise. 8.04. What is the difference between the Bank branche(per 100,000 adults) of Hungary in 2009 and the Bank branche(per 100,000 adults) of Sri Lanka in 2010?
Ensure brevity in your answer.  2.09. What is the difference between the Bank branche(per 100,000 adults) in Caribbean small states in 2009 and the Bank branche(per 100,000 adults) in Hong Kong in 2011?
Ensure brevity in your answer.  -14.04. What is the difference between the Bank branche(per 100,000 adults) of Caribbean small states in 2009 and the Bank branche(per 100,000 adults) of Hungary in 2011?
Keep it short and to the point. -6.55. What is the difference between the Bank branche(per 100,000 adults) of Caribbean small states in 2009 and the Bank branche(per 100,000 adults) of Sri Lanka in 2011?
Offer a terse response. -6.99. What is the difference between the Bank branche(per 100,000 adults) in Hong Kong in 2009 and the Bank branche(per 100,000 adults) in Hungary in 2011?
Your response must be concise. 7.13. What is the difference between the Bank branche(per 100,000 adults) in Hong Kong in 2009 and the Bank branche(per 100,000 adults) in Sri Lanka in 2011?
Your answer should be very brief. 6.69. What is the difference between the Bank branche(per 100,000 adults) of Hungary in 2009 and the Bank branche(per 100,000 adults) of Sri Lanka in 2011?
Your answer should be very brief. 0.74. What is the difference between the Bank branche(per 100,000 adults) in Caribbean small states in 2010 and the Bank branche(per 100,000 adults) in Hong Kong in 2011?
Ensure brevity in your answer.  -13.86. What is the difference between the Bank branche(per 100,000 adults) of Caribbean small states in 2010 and the Bank branche(per 100,000 adults) of Hungary in 2011?
Your answer should be compact. -6.38. What is the difference between the Bank branche(per 100,000 adults) in Caribbean small states in 2010 and the Bank branche(per 100,000 adults) in Sri Lanka in 2011?
Make the answer very short. -6.82. What is the difference between the Bank branche(per 100,000 adults) of Hong Kong in 2010 and the Bank branche(per 100,000 adults) of Hungary in 2011?
Offer a terse response. 7.48. What is the difference between the Bank branche(per 100,000 adults) of Hong Kong in 2010 and the Bank branche(per 100,000 adults) of Sri Lanka in 2011?
Provide a succinct answer. 7.04. What is the difference between the Bank branche(per 100,000 adults) of Hungary in 2010 and the Bank branche(per 100,000 adults) of Sri Lanka in 2011?
Provide a short and direct response. -0.12. What is the average Bank branche(per 100,000 adults) of Caribbean small states per year?
Give a very brief answer. 9.85. What is the average Bank branche(per 100,000 adults) of Hong Kong per year?
Offer a very short reply. 23.55. What is the average Bank branche(per 100,000 adults) of Hungary per year?
Provide a short and direct response. 16.7. What is the average Bank branche(per 100,000 adults) of Sri Lanka per year?
Keep it short and to the point. 13.52. In the year 2005, what is the difference between the Bank branche(per 100,000 adults) in Caribbean small states and Bank branche(per 100,000 adults) in Hong Kong?
Provide a succinct answer. -13.45. In the year 2005, what is the difference between the Bank branche(per 100,000 adults) in Caribbean small states and Bank branche(per 100,000 adults) in Hungary?
Your answer should be compact. -5.05. In the year 2005, what is the difference between the Bank branche(per 100,000 adults) in Caribbean small states and Bank branche(per 100,000 adults) in Sri Lanka?
Offer a very short reply. 0.82. In the year 2005, what is the difference between the Bank branche(per 100,000 adults) in Hong Kong and Bank branche(per 100,000 adults) in Hungary?
Make the answer very short. 8.4. In the year 2005, what is the difference between the Bank branche(per 100,000 adults) of Hong Kong and Bank branche(per 100,000 adults) of Sri Lanka?
Your answer should be very brief. 14.26. In the year 2005, what is the difference between the Bank branche(per 100,000 adults) of Hungary and Bank branche(per 100,000 adults) of Sri Lanka?
Offer a very short reply. 5.86. In the year 2006, what is the difference between the Bank branche(per 100,000 adults) in Caribbean small states and Bank branche(per 100,000 adults) in Hong Kong?
Offer a terse response. -13.21. In the year 2006, what is the difference between the Bank branche(per 100,000 adults) in Caribbean small states and Bank branche(per 100,000 adults) in Hungary?
Offer a very short reply. -6.28. In the year 2006, what is the difference between the Bank branche(per 100,000 adults) of Caribbean small states and Bank branche(per 100,000 adults) of Sri Lanka?
Offer a very short reply. -2.02. In the year 2006, what is the difference between the Bank branche(per 100,000 adults) of Hong Kong and Bank branche(per 100,000 adults) of Hungary?
Provide a short and direct response. 6.93. In the year 2006, what is the difference between the Bank branche(per 100,000 adults) of Hong Kong and Bank branche(per 100,000 adults) of Sri Lanka?
Your answer should be very brief. 11.19. In the year 2006, what is the difference between the Bank branche(per 100,000 adults) in Hungary and Bank branche(per 100,000 adults) in Sri Lanka?
Your answer should be compact. 4.26. In the year 2007, what is the difference between the Bank branche(per 100,000 adults) in Caribbean small states and Bank branche(per 100,000 adults) in Hong Kong?
Provide a succinct answer. -13.5. In the year 2007, what is the difference between the Bank branche(per 100,000 adults) in Caribbean small states and Bank branche(per 100,000 adults) in Hungary?
Your answer should be compact. -7.36. In the year 2007, what is the difference between the Bank branche(per 100,000 adults) in Caribbean small states and Bank branche(per 100,000 adults) in Sri Lanka?
Your response must be concise. -3.14. In the year 2007, what is the difference between the Bank branche(per 100,000 adults) of Hong Kong and Bank branche(per 100,000 adults) of Hungary?
Ensure brevity in your answer.  6.14. In the year 2007, what is the difference between the Bank branche(per 100,000 adults) in Hong Kong and Bank branche(per 100,000 adults) in Sri Lanka?
Make the answer very short. 10.36. In the year 2007, what is the difference between the Bank branche(per 100,000 adults) in Hungary and Bank branche(per 100,000 adults) in Sri Lanka?
Ensure brevity in your answer.  4.22. In the year 2008, what is the difference between the Bank branche(per 100,000 adults) in Caribbean small states and Bank branche(per 100,000 adults) in Hong Kong?
Keep it short and to the point. -13.79. In the year 2008, what is the difference between the Bank branche(per 100,000 adults) of Caribbean small states and Bank branche(per 100,000 adults) of Hungary?
Provide a short and direct response. -7.91. In the year 2008, what is the difference between the Bank branche(per 100,000 adults) of Caribbean small states and Bank branche(per 100,000 adults) of Sri Lanka?
Give a very brief answer. -3.81. In the year 2008, what is the difference between the Bank branche(per 100,000 adults) in Hong Kong and Bank branche(per 100,000 adults) in Hungary?
Ensure brevity in your answer.  5.88. In the year 2008, what is the difference between the Bank branche(per 100,000 adults) in Hong Kong and Bank branche(per 100,000 adults) in Sri Lanka?
Make the answer very short. 9.97. In the year 2008, what is the difference between the Bank branche(per 100,000 adults) in Hungary and Bank branche(per 100,000 adults) in Sri Lanka?
Ensure brevity in your answer.  4.09. In the year 2009, what is the difference between the Bank branche(per 100,000 adults) in Caribbean small states and Bank branche(per 100,000 adults) in Hong Kong?
Provide a succinct answer. -13.69. In the year 2009, what is the difference between the Bank branche(per 100,000 adults) in Caribbean small states and Bank branche(per 100,000 adults) in Hungary?
Ensure brevity in your answer.  -7.74. In the year 2009, what is the difference between the Bank branche(per 100,000 adults) of Caribbean small states and Bank branche(per 100,000 adults) of Sri Lanka?
Provide a succinct answer. -4.73. In the year 2009, what is the difference between the Bank branche(per 100,000 adults) in Hong Kong and Bank branche(per 100,000 adults) in Hungary?
Offer a terse response. 5.95. In the year 2009, what is the difference between the Bank branche(per 100,000 adults) of Hong Kong and Bank branche(per 100,000 adults) of Sri Lanka?
Provide a succinct answer. 8.96. In the year 2009, what is the difference between the Bank branche(per 100,000 adults) in Hungary and Bank branche(per 100,000 adults) in Sri Lanka?
Make the answer very short. 3.01. In the year 2010, what is the difference between the Bank branche(per 100,000 adults) in Caribbean small states and Bank branche(per 100,000 adults) in Hong Kong?
Provide a succinct answer. -13.86. In the year 2010, what is the difference between the Bank branche(per 100,000 adults) of Caribbean small states and Bank branche(per 100,000 adults) of Hungary?
Your answer should be compact. -6.7. In the year 2010, what is the difference between the Bank branche(per 100,000 adults) in Caribbean small states and Bank branche(per 100,000 adults) in Sri Lanka?
Ensure brevity in your answer.  -5.46. In the year 2010, what is the difference between the Bank branche(per 100,000 adults) in Hong Kong and Bank branche(per 100,000 adults) in Hungary?
Keep it short and to the point. 7.16. In the year 2010, what is the difference between the Bank branche(per 100,000 adults) in Hong Kong and Bank branche(per 100,000 adults) in Sri Lanka?
Offer a very short reply. 8.39. In the year 2010, what is the difference between the Bank branche(per 100,000 adults) in Hungary and Bank branche(per 100,000 adults) in Sri Lanka?
Your response must be concise. 1.24. In the year 2011, what is the difference between the Bank branche(per 100,000 adults) in Caribbean small states and Bank branche(per 100,000 adults) in Hong Kong?
Your answer should be compact. -14.38. In the year 2011, what is the difference between the Bank branche(per 100,000 adults) in Caribbean small states and Bank branche(per 100,000 adults) in Hungary?
Your response must be concise. -6.89. In the year 2011, what is the difference between the Bank branche(per 100,000 adults) of Caribbean small states and Bank branche(per 100,000 adults) of Sri Lanka?
Offer a very short reply. -7.33. In the year 2011, what is the difference between the Bank branche(per 100,000 adults) in Hong Kong and Bank branche(per 100,000 adults) in Hungary?
Offer a very short reply. 7.49. In the year 2011, what is the difference between the Bank branche(per 100,000 adults) in Hong Kong and Bank branche(per 100,000 adults) in Sri Lanka?
Provide a short and direct response. 7.05. In the year 2011, what is the difference between the Bank branche(per 100,000 adults) of Hungary and Bank branche(per 100,000 adults) of Sri Lanka?
Your answer should be compact. -0.44. What is the ratio of the Bank branche(per 100,000 adults) of Hong Kong in 2005 to that in 2006?
Offer a very short reply. 1.01. What is the ratio of the Bank branche(per 100,000 adults) in Hungary in 2005 to that in 2006?
Provide a short and direct response. 0.92. What is the ratio of the Bank branche(per 100,000 adults) in Sri Lanka in 2005 to that in 2006?
Provide a short and direct response. 0.75. What is the ratio of the Bank branche(per 100,000 adults) of Caribbean small states in 2005 to that in 2007?
Make the answer very short. 0.98. What is the ratio of the Bank branche(per 100,000 adults) of Hungary in 2005 to that in 2007?
Your response must be concise. 0.86. What is the ratio of the Bank branche(per 100,000 adults) in Sri Lanka in 2005 to that in 2007?
Your answer should be very brief. 0.68. What is the ratio of the Bank branche(per 100,000 adults) of Caribbean small states in 2005 to that in 2008?
Make the answer very short. 0.97. What is the ratio of the Bank branche(per 100,000 adults) of Hong Kong in 2005 to that in 2008?
Your response must be concise. 0.97. What is the ratio of the Bank branche(per 100,000 adults) in Hungary in 2005 to that in 2008?
Give a very brief answer. 0.83. What is the ratio of the Bank branche(per 100,000 adults) in Sri Lanka in 2005 to that in 2008?
Your response must be concise. 0.65. What is the ratio of the Bank branche(per 100,000 adults) in Caribbean small states in 2005 to that in 2009?
Make the answer very short. 0.99. What is the ratio of the Bank branche(per 100,000 adults) in Hong Kong in 2005 to that in 2009?
Your response must be concise. 0.99. What is the ratio of the Bank branche(per 100,000 adults) in Hungary in 2005 to that in 2009?
Provide a short and direct response. 0.84. What is the ratio of the Bank branche(per 100,000 adults) in Sri Lanka in 2005 to that in 2009?
Offer a terse response. 0.61. What is the ratio of the Bank branche(per 100,000 adults) in Caribbean small states in 2005 to that in 2010?
Keep it short and to the point. 0.97. What is the ratio of the Bank branche(per 100,000 adults) in Hong Kong in 2005 to that in 2010?
Make the answer very short. 0.97. What is the ratio of the Bank branche(per 100,000 adults) in Hungary in 2005 to that in 2010?
Offer a very short reply. 0.88. What is the ratio of the Bank branche(per 100,000 adults) of Sri Lanka in 2005 to that in 2010?
Keep it short and to the point. 0.58. What is the ratio of the Bank branche(per 100,000 adults) in Caribbean small states in 2005 to that in 2011?
Your answer should be compact. 1.02. What is the ratio of the Bank branche(per 100,000 adults) in Hong Kong in 2005 to that in 2011?
Offer a very short reply. 0.97. What is the ratio of the Bank branche(per 100,000 adults) of Hungary in 2005 to that in 2011?
Ensure brevity in your answer.  0.9. What is the ratio of the Bank branche(per 100,000 adults) of Sri Lanka in 2005 to that in 2011?
Offer a very short reply. 0.53. What is the ratio of the Bank branche(per 100,000 adults) of Caribbean small states in 2006 to that in 2007?
Provide a short and direct response. 0.99. What is the ratio of the Bank branche(per 100,000 adults) in Hong Kong in 2006 to that in 2007?
Offer a very short reply. 0.98. What is the ratio of the Bank branche(per 100,000 adults) of Hungary in 2006 to that in 2007?
Your answer should be very brief. 0.93. What is the ratio of the Bank branche(per 100,000 adults) in Sri Lanka in 2006 to that in 2007?
Offer a very short reply. 0.91. What is the ratio of the Bank branche(per 100,000 adults) in Caribbean small states in 2006 to that in 2008?
Your answer should be very brief. 0.98. What is the ratio of the Bank branche(per 100,000 adults) in Hong Kong in 2006 to that in 2008?
Offer a terse response. 0.97. What is the ratio of the Bank branche(per 100,000 adults) in Hungary in 2006 to that in 2008?
Provide a short and direct response. 0.9. What is the ratio of the Bank branche(per 100,000 adults) of Sri Lanka in 2006 to that in 2008?
Give a very brief answer. 0.86. What is the ratio of the Bank branche(per 100,000 adults) of Caribbean small states in 2006 to that in 2009?
Make the answer very short. 1. What is the ratio of the Bank branche(per 100,000 adults) of Hong Kong in 2006 to that in 2009?
Your response must be concise. 0.98. What is the ratio of the Bank branche(per 100,000 adults) in Hungary in 2006 to that in 2009?
Provide a short and direct response. 0.92. What is the ratio of the Bank branche(per 100,000 adults) of Sri Lanka in 2006 to that in 2009?
Your answer should be compact. 0.81. What is the ratio of the Bank branche(per 100,000 adults) in Caribbean small states in 2006 to that in 2010?
Keep it short and to the point. 0.98. What is the ratio of the Bank branche(per 100,000 adults) of Hong Kong in 2006 to that in 2010?
Your answer should be compact. 0.96. What is the ratio of the Bank branche(per 100,000 adults) in Hungary in 2006 to that in 2010?
Provide a succinct answer. 0.96. What is the ratio of the Bank branche(per 100,000 adults) of Sri Lanka in 2006 to that in 2010?
Offer a very short reply. 0.76. What is the ratio of the Bank branche(per 100,000 adults) in Caribbean small states in 2006 to that in 2011?
Ensure brevity in your answer.  1.03. What is the ratio of the Bank branche(per 100,000 adults) in Hong Kong in 2006 to that in 2011?
Your answer should be compact. 0.96. What is the ratio of the Bank branche(per 100,000 adults) in Hungary in 2006 to that in 2011?
Provide a short and direct response. 0.98. What is the ratio of the Bank branche(per 100,000 adults) in Sri Lanka in 2006 to that in 2011?
Provide a succinct answer. 0.7. What is the ratio of the Bank branche(per 100,000 adults) of Hong Kong in 2007 to that in 2008?
Provide a short and direct response. 0.98. What is the ratio of the Bank branche(per 100,000 adults) of Hungary in 2007 to that in 2008?
Your answer should be compact. 0.96. What is the ratio of the Bank branche(per 100,000 adults) of Sri Lanka in 2007 to that in 2008?
Your answer should be very brief. 0.94. What is the ratio of the Bank branche(per 100,000 adults) of Caribbean small states in 2007 to that in 2009?
Ensure brevity in your answer.  1.01. What is the ratio of the Bank branche(per 100,000 adults) of Hong Kong in 2007 to that in 2009?
Your response must be concise. 0.99. What is the ratio of the Bank branche(per 100,000 adults) in Hungary in 2007 to that in 2009?
Your response must be concise. 0.98. What is the ratio of the Bank branche(per 100,000 adults) in Sri Lanka in 2007 to that in 2009?
Keep it short and to the point. 0.9. What is the ratio of the Bank branche(per 100,000 adults) in Caribbean small states in 2007 to that in 2010?
Keep it short and to the point. 0.99. What is the ratio of the Bank branche(per 100,000 adults) of Hong Kong in 2007 to that in 2010?
Offer a terse response. 0.98. What is the ratio of the Bank branche(per 100,000 adults) of Hungary in 2007 to that in 2010?
Provide a succinct answer. 1.03. What is the ratio of the Bank branche(per 100,000 adults) in Sri Lanka in 2007 to that in 2010?
Keep it short and to the point. 0.84. What is the ratio of the Bank branche(per 100,000 adults) in Caribbean small states in 2007 to that in 2011?
Your response must be concise. 1.04. What is the ratio of the Bank branche(per 100,000 adults) of Hong Kong in 2007 to that in 2011?
Make the answer very short. 0.98. What is the ratio of the Bank branche(per 100,000 adults) in Hungary in 2007 to that in 2011?
Your answer should be very brief. 1.05. What is the ratio of the Bank branche(per 100,000 adults) in Sri Lanka in 2007 to that in 2011?
Offer a very short reply. 0.77. What is the ratio of the Bank branche(per 100,000 adults) of Caribbean small states in 2008 to that in 2009?
Provide a short and direct response. 1.02. What is the ratio of the Bank branche(per 100,000 adults) of Hong Kong in 2008 to that in 2009?
Provide a succinct answer. 1.01. What is the ratio of the Bank branche(per 100,000 adults) of Hungary in 2008 to that in 2009?
Give a very brief answer. 1.02. What is the ratio of the Bank branche(per 100,000 adults) in Sri Lanka in 2008 to that in 2009?
Ensure brevity in your answer.  0.95. What is the ratio of the Bank branche(per 100,000 adults) in Caribbean small states in 2008 to that in 2010?
Your answer should be compact. 1. What is the ratio of the Bank branche(per 100,000 adults) of Hong Kong in 2008 to that in 2010?
Provide a short and direct response. 1. What is the ratio of the Bank branche(per 100,000 adults) of Hungary in 2008 to that in 2010?
Offer a very short reply. 1.07. What is the ratio of the Bank branche(per 100,000 adults) of Sri Lanka in 2008 to that in 2010?
Ensure brevity in your answer.  0.89. What is the ratio of the Bank branche(per 100,000 adults) in Caribbean small states in 2008 to that in 2011?
Provide a short and direct response. 1.05. What is the ratio of the Bank branche(per 100,000 adults) in Hungary in 2008 to that in 2011?
Keep it short and to the point. 1.09. What is the ratio of the Bank branche(per 100,000 adults) of Sri Lanka in 2008 to that in 2011?
Provide a short and direct response. 0.82. What is the ratio of the Bank branche(per 100,000 adults) in Caribbean small states in 2009 to that in 2010?
Give a very brief answer. 0.98. What is the ratio of the Bank branche(per 100,000 adults) of Hong Kong in 2009 to that in 2010?
Provide a succinct answer. 0.99. What is the ratio of the Bank branche(per 100,000 adults) in Hungary in 2009 to that in 2010?
Give a very brief answer. 1.05. What is the ratio of the Bank branche(per 100,000 adults) in Sri Lanka in 2009 to that in 2010?
Your response must be concise. 0.94. What is the ratio of the Bank branche(per 100,000 adults) of Caribbean small states in 2009 to that in 2011?
Give a very brief answer. 1.04. What is the ratio of the Bank branche(per 100,000 adults) of Hong Kong in 2009 to that in 2011?
Give a very brief answer. 0.99. What is the ratio of the Bank branche(per 100,000 adults) in Hungary in 2009 to that in 2011?
Your answer should be very brief. 1.07. What is the ratio of the Bank branche(per 100,000 adults) in Sri Lanka in 2009 to that in 2011?
Make the answer very short. 0.87. What is the ratio of the Bank branche(per 100,000 adults) in Caribbean small states in 2010 to that in 2011?
Keep it short and to the point. 1.05. What is the ratio of the Bank branche(per 100,000 adults) of Hong Kong in 2010 to that in 2011?
Your response must be concise. 1. What is the ratio of the Bank branche(per 100,000 adults) of Hungary in 2010 to that in 2011?
Provide a succinct answer. 1.02. What is the ratio of the Bank branche(per 100,000 adults) of Sri Lanka in 2010 to that in 2011?
Provide a short and direct response. 0.92. What is the difference between the highest and the second highest Bank branche(per 100,000 adults) in Caribbean small states?
Provide a succinct answer. 0.02. What is the difference between the highest and the second highest Bank branche(per 100,000 adults) in Hong Kong?
Make the answer very short. 0.01. What is the difference between the highest and the second highest Bank branche(per 100,000 adults) in Hungary?
Your response must be concise. 0.33. What is the difference between the highest and the second highest Bank branche(per 100,000 adults) of Sri Lanka?
Your response must be concise. 1.35. What is the difference between the highest and the lowest Bank branche(per 100,000 adults) of Caribbean small states?
Your answer should be very brief. 0.52. What is the difference between the highest and the lowest Bank branche(per 100,000 adults) in Hong Kong?
Offer a very short reply. 0.86. What is the difference between the highest and the lowest Bank branche(per 100,000 adults) in Hungary?
Keep it short and to the point. 3.12. What is the difference between the highest and the lowest Bank branche(per 100,000 adults) of Sri Lanka?
Your answer should be very brief. 7.92. 